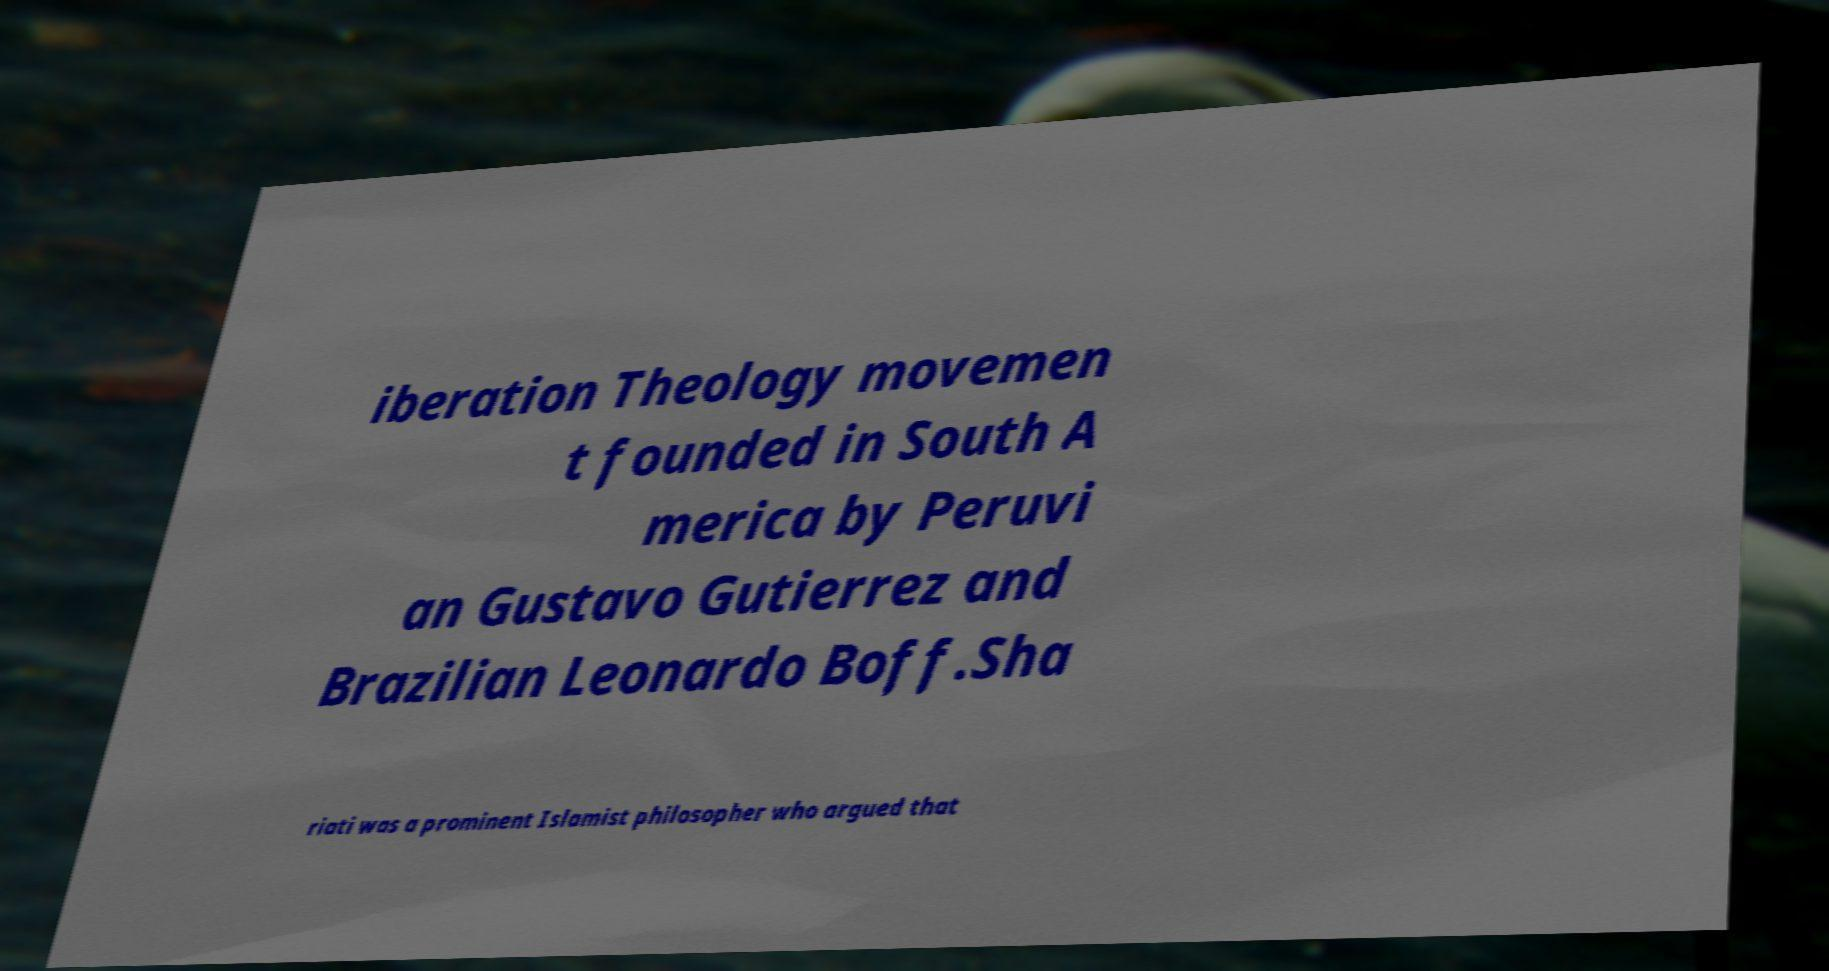Can you read and provide the text displayed in the image?This photo seems to have some interesting text. Can you extract and type it out for me? iberation Theology movemen t founded in South A merica by Peruvi an Gustavo Gutierrez and Brazilian Leonardo Boff.Sha riati was a prominent Islamist philosopher who argued that 